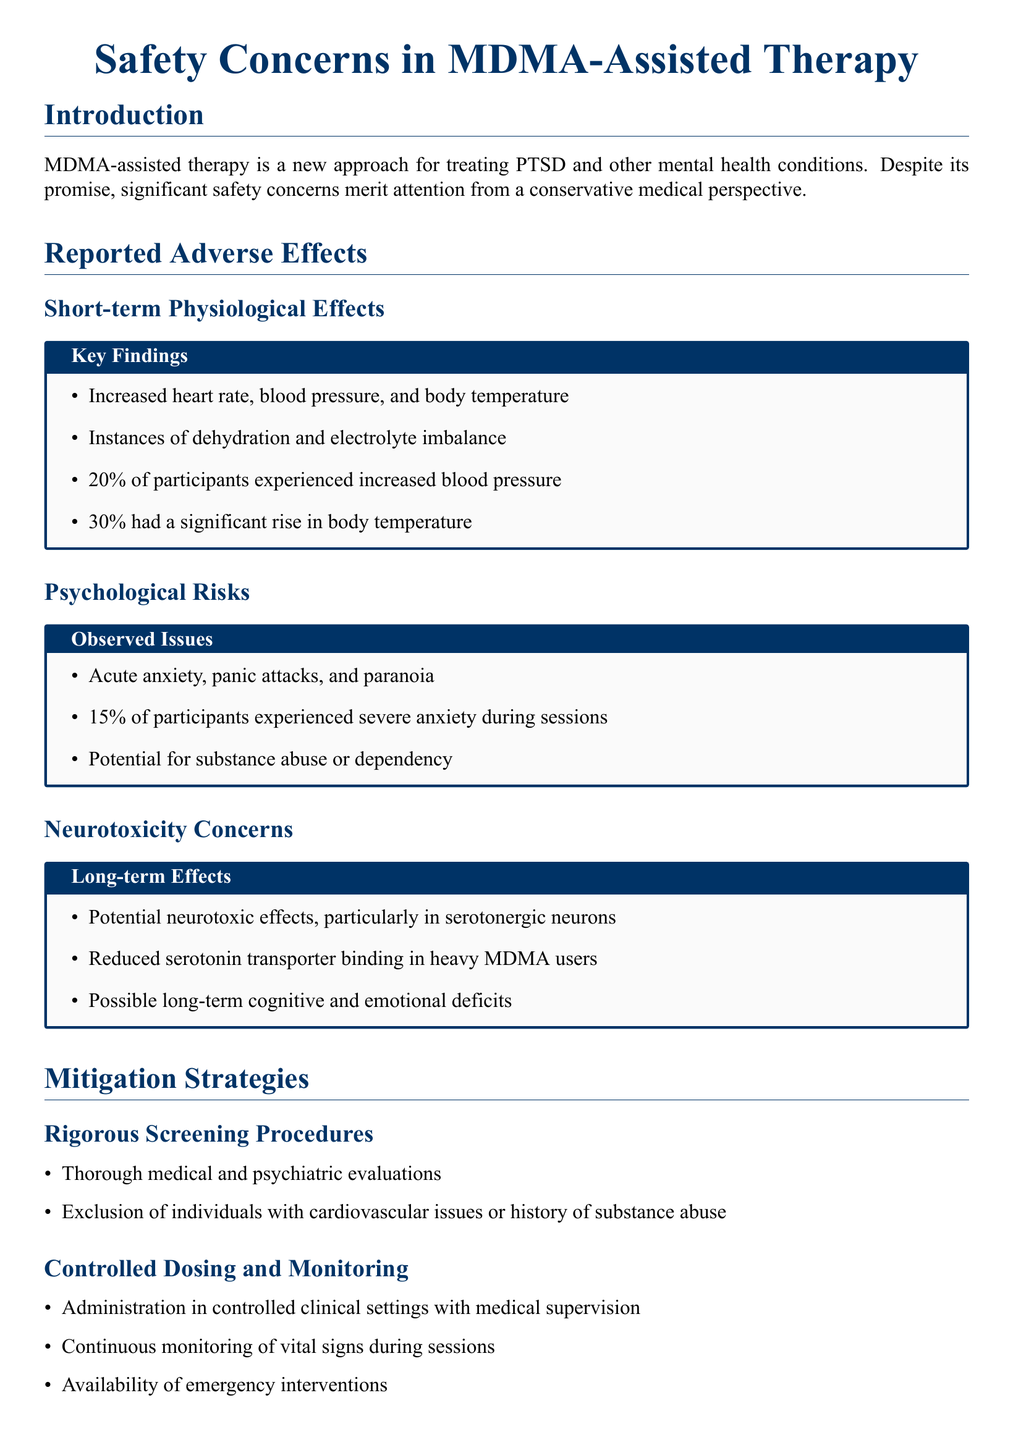What percentage of participants experienced increased blood pressure? The document states that 20% of participants experienced increased blood pressure during MDMA-assisted therapy.
Answer: 20% What is a short-term physiological effect of MDMA? Increased heart rate is one of the listed short-term physiological effects in the document.
Answer: Increased heart rate What is one psychological risk associated with MDMA use? The document mentions acute anxiety as one of the psychological risks during therapy sessions.
Answer: Acute anxiety What percentage of participants experienced severe anxiety? The document records that 15% of participants experienced severe anxiety during the therapy sessions.
Answer: 15% What concern is related to long-term effects of MDMA? The document highlights potential neurotoxic effects as a concern regarding long-term use.
Answer: Neurotoxic effects What type of screening is emphasized in mitigation strategies? Rigorous screening procedures are underscored in the mitigation strategies section.
Answer: Rigorous screening What is a key aspect of controlled dosing and monitoring? Continuous monitoring of vital signs during sessions is a key aspect mentioned in the mitigation strategies.
Answer: Continuous monitoring What type of support is important after MDMA sessions? The document emphasizes comprehensive aftercare as an important type of support following MDMA sessions.
Answer: Comprehensive aftercare 